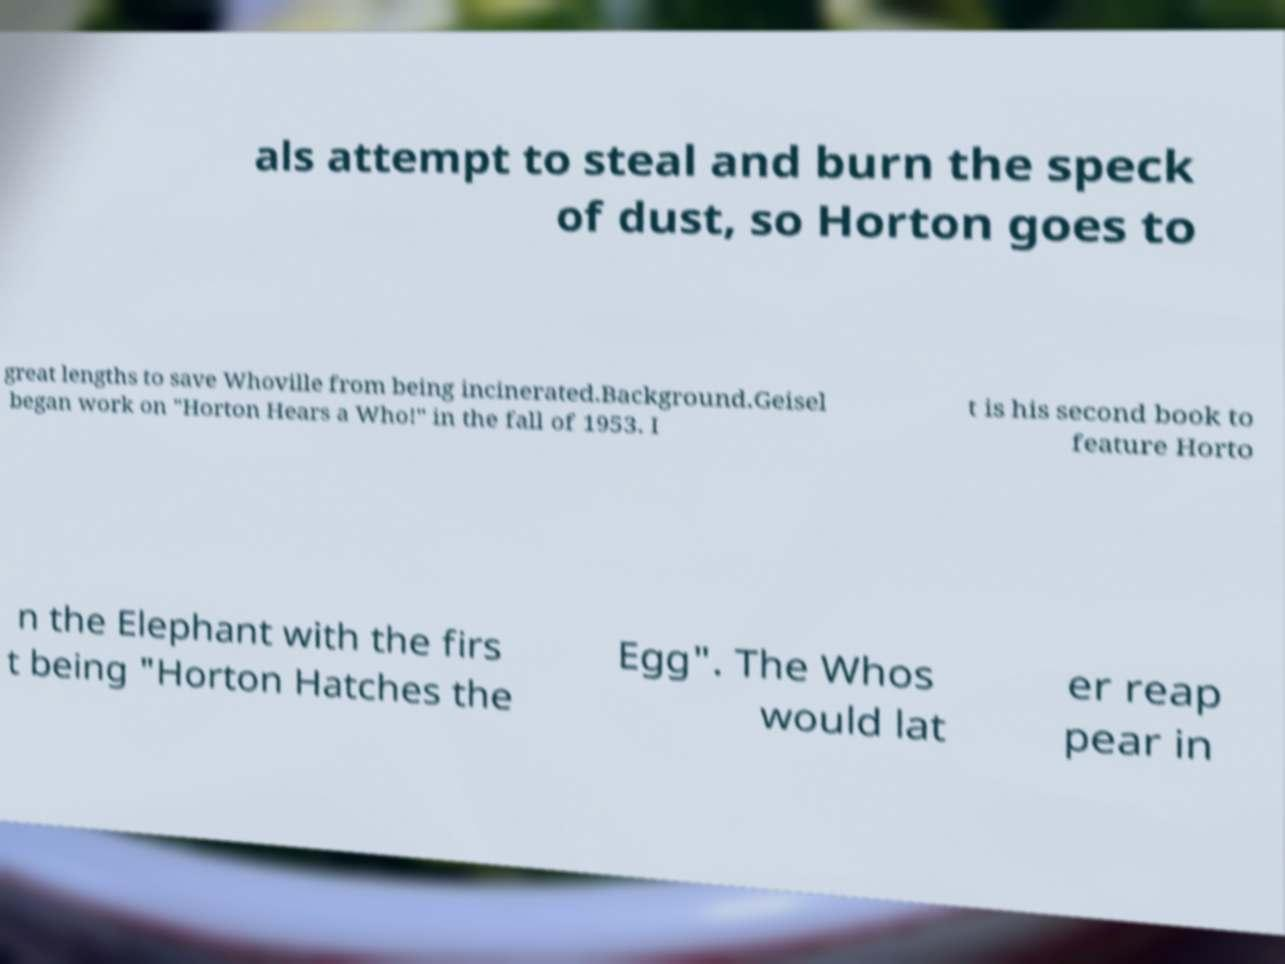Please identify and transcribe the text found in this image. als attempt to steal and burn the speck of dust, so Horton goes to great lengths to save Whoville from being incinerated.Background.Geisel began work on "Horton Hears a Who!" in the fall of 1953. I t is his second book to feature Horto n the Elephant with the firs t being "Horton Hatches the Egg". The Whos would lat er reap pear in 